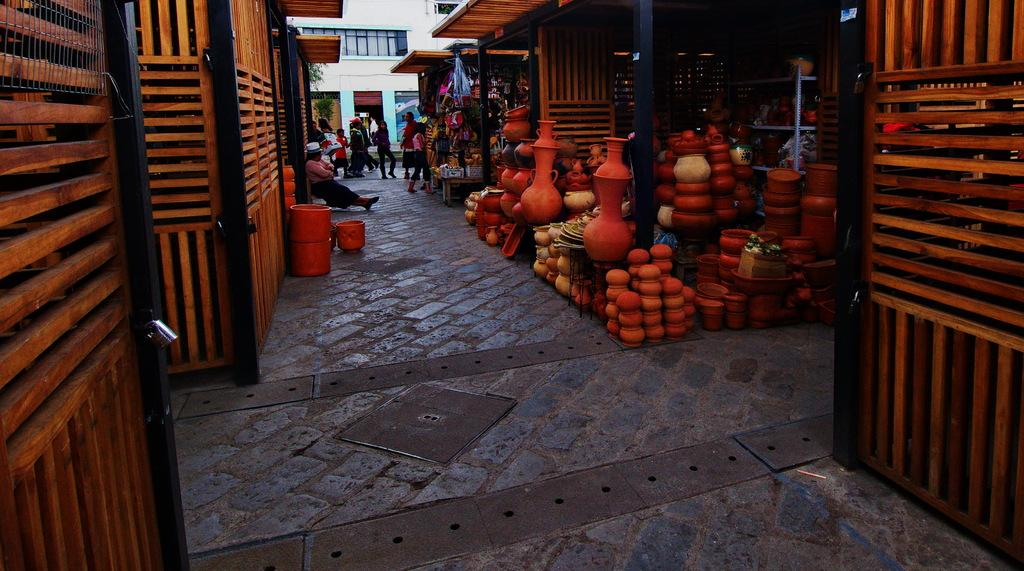What is depicted in the image? There are stories in the image. What are the people in the image doing? There are people standing and walking in the image. What type of structures can be seen in the image? There are wooden sheds in the image. What is located at the top of the image? There is a building at the top of the image. What direction is the pot facing in the image? There is no pot present in the image. How long is the voyage depicted in the image? There is no voyage depicted in the image; it features stories, people, wooden sheds, and a building. 